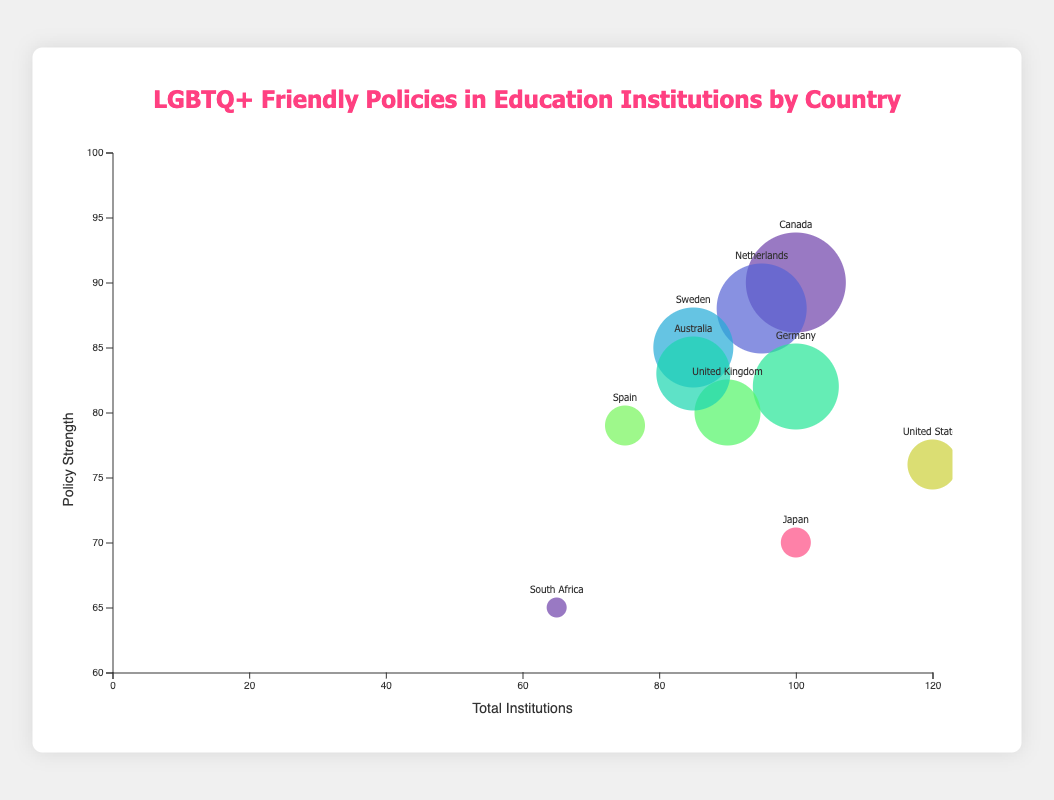Which country has the strongest LGBTQ+ friendly policies based on policy strength? The policy strength for each country is represented by the y-axis. By locating the highest point on the y-axis, we see that Canada, with a policy strength of 90, has the strongest LGBTQ+ friendly policies.
Answer: Canada Which country has the largest number of education institutions with LGBTQ+ friendly policies? The size of each bubble represents the number of institutions with LGBTQ+ friendly policies. The largest bubble corresponds to Canada, which has the most institutions with such policies.
Answer: Canada Which country has the lowest policy strength? The policy strength is shown on the y-axis. The country with the lowest y-axis value (65) is South Africa.
Answer: South Africa How many total education institutions does the United States have, and how many of them have LGBTQ+ friendly policies? The United States' total institutions are represented on the x-axis, and the size of the bubble represents the institutions with policies. Referring to the tooltip or bubble positioning, the United States has 120 total institutions, with 60 having friendly policies.
Answer: 120 total, 60 with policies What is the policy strength difference between the Netherlands and Japan? The policy strength of the Netherlands is 88, while Japan's policy strength is 70. The difference is calculated as 88 - 70 = 18.
Answer: 18 Which country has more educational institutions with LGBTQ+ friendly policies: Germany or Japan? By comparing the sizes of the bubbles for Germany and Japan, Germany's bubble is larger. The tooltip can confirm the numbers: Germany (78) has more than Japan (50).
Answer: Germany What is the average policy strength of the countries with a policy strength greater than 80? The countries with policy strengths greater than 80 are Canada (90), Netherlands (88), Sweden (85), Germany (82), and Australia (83). Calculating the mean: (90 + 88 + 85 + 82 + 83) / 5 = 85.6.
Answer: 85.6 Is there any country with more than 100 educational institutions but less than 50 institutions with LGBTQ+ friendly policies? By checking the x-axis (>100) and bubble sizes (<50), Japan fits this criterion with 100 total institutions and 50 institutions with policies.
Answer: Japan Which country has a policy strength closest to the average policy strength of all countries? Calculating the average policy strength: (90 + 88 + 85 + 82 + 76 + 80 + 83 + 79 + 70 + 65) / 10 = 79.8. The country closest to 79.8 is Spain, with a policy strength of 79.
Answer: Spain 